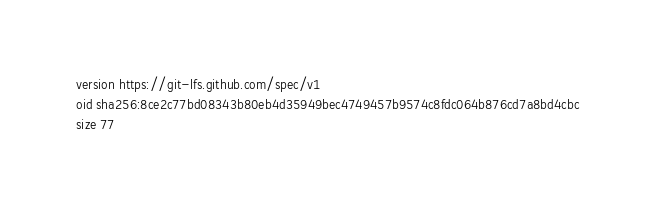Convert code to text. <code><loc_0><loc_0><loc_500><loc_500><_YAML_>version https://git-lfs.github.com/spec/v1
oid sha256:8ce2c77bd08343b80eb4d35949bec4749457b9574c8fdc064b876cd7a8bd4cbc
size 77
</code> 